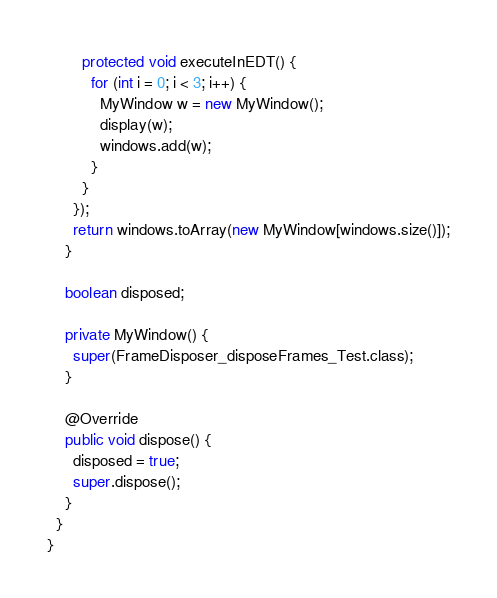<code> <loc_0><loc_0><loc_500><loc_500><_Java_>        protected void executeInEDT() {
          for (int i = 0; i < 3; i++) {
            MyWindow w = new MyWindow();
            display(w);
            windows.add(w);
          }
        }
      });
      return windows.toArray(new MyWindow[windows.size()]);
    }

    boolean disposed;

    private MyWindow() {
      super(FrameDisposer_disposeFrames_Test.class);
    }

    @Override
    public void dispose() {
      disposed = true;
      super.dispose();
    }
  }
}
</code> 